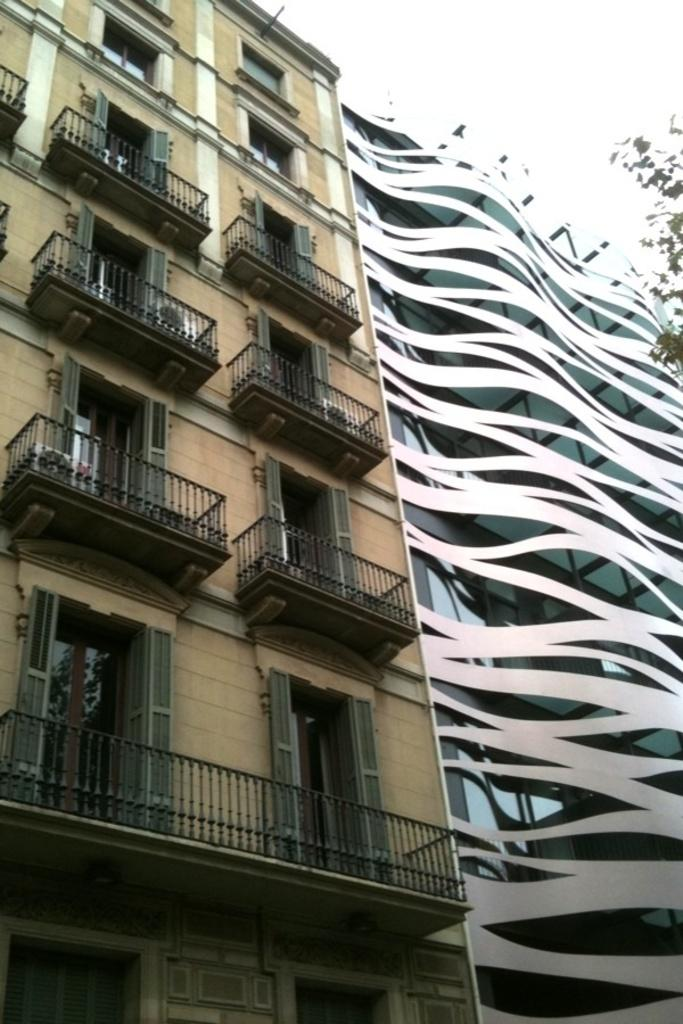What structures are present in the image? There are buildings in the image. What features can be observed on the buildings? The buildings have windows and fences. What type of wind can be seen blowing through the cushion in the image? There is no cushion present in the image, and therefore no wind blowing through it. What type of bushes are growing near the buildings in the image? There is no mention of bushes in the provided facts, so we cannot determine if any bushes are present near the buildings. 